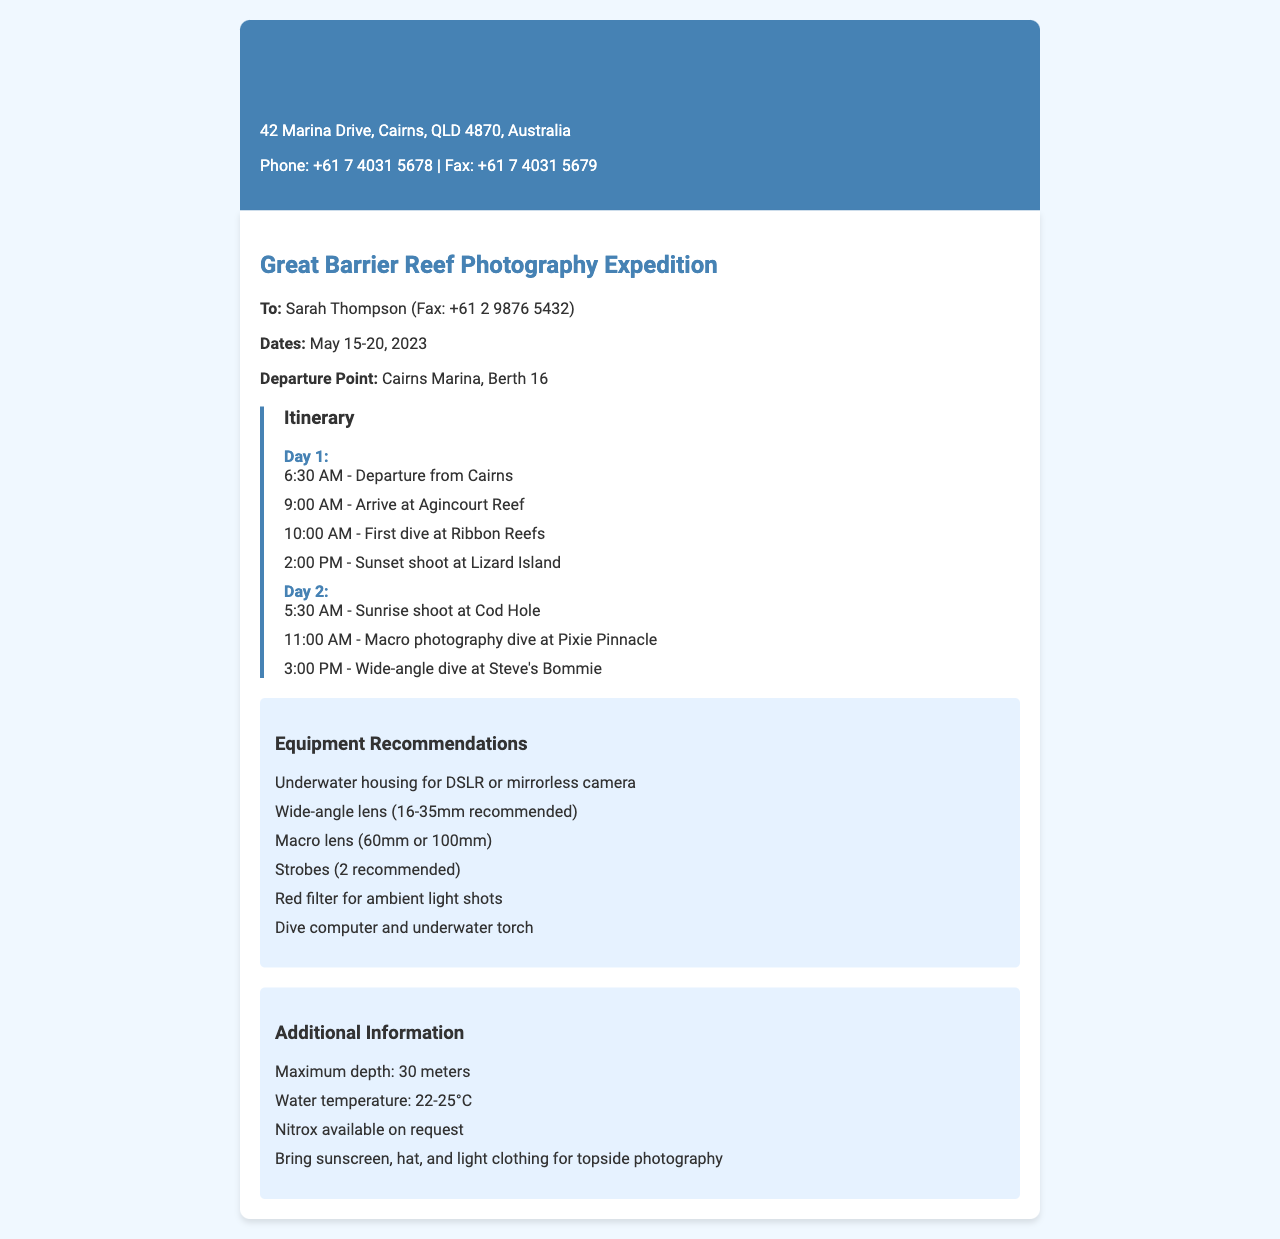What are the dates of the expedition? The dates of the expedition are clearly mentioned in the document as May 15-20, 2023.
Answer: May 15-20, 2023 What time does the first dive start on Day 1? The first dive on Day 1 is specified in the itinerary to start at 10:00 AM.
Answer: 10:00 AM What location is scheduled for a sunset shoot? The document indicates that the sunset shoot is planned at Lizard Island.
Answer: Lizard Island What equipment is recommended for underwater photography? The document lists several pieces of equipment, including underwater housing for DSLR or mirrorless camera as the first recommendation.
Answer: Underwater housing for DSLR or mirrorless camera How many dives are planned on Day 2? The itinerary for Day 2 includes two dives, a macro photography dive and a wide-angle dive.
Answer: Two dives What is the maximum depth mentioned for diving? The maximum depth for diving specified in the additional information is 30 meters.
Answer: 30 meters What is the water temperature range during the expedition? The water temperature range is provided in the additional information as 22-25°C.
Answer: 22-25°C What time is the sunrise shoot scheduled on Day 2? The itinerary states that the sunrise shoot on Day 2 is set for 5:30 AM.
Answer: 5:30 AM Is Nitrox available during the dives? The additional information section confirms that Nitrox is available on request during the dives.
Answer: Yes, on request 